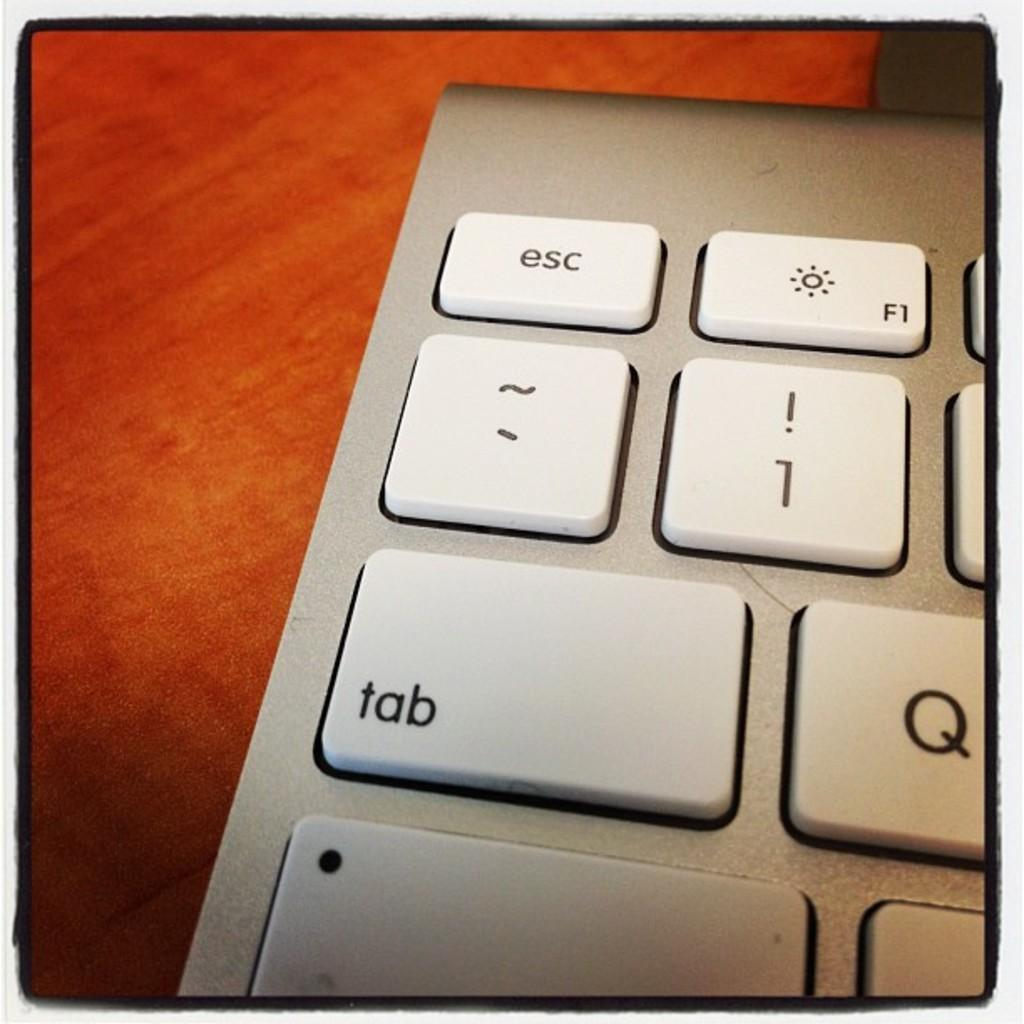<image>
Summarize the visual content of the image. A zoomed in keyboard with the tab and Q keys prominent. 